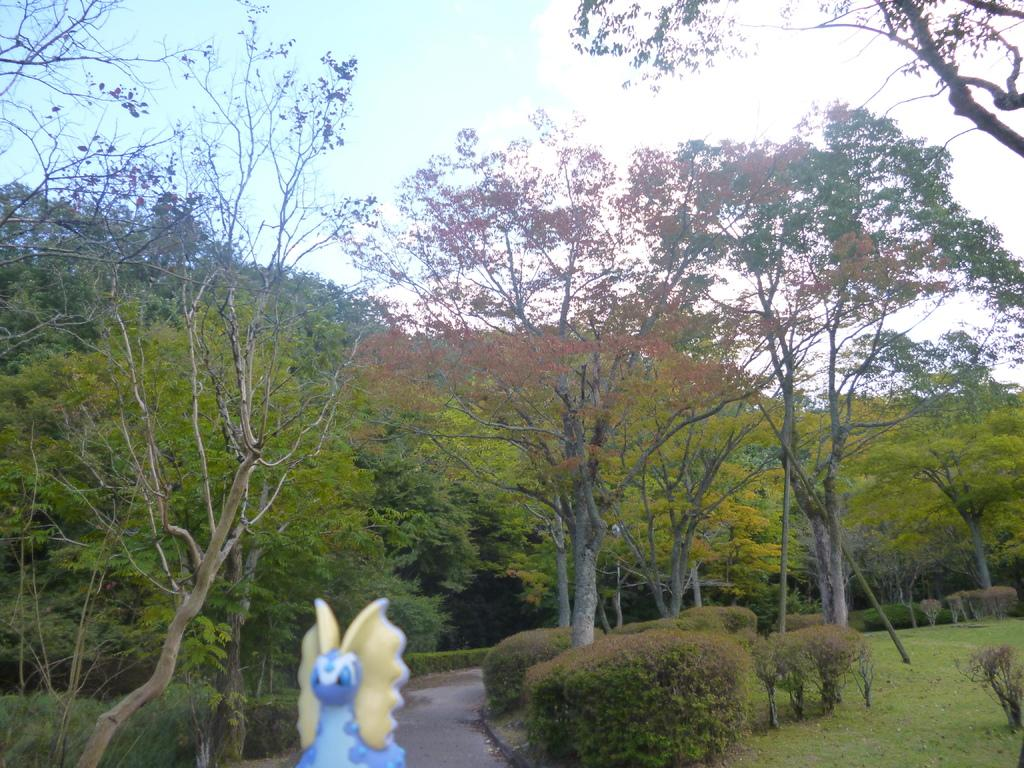What is the main subject of the image? There is a sculpture in the image. What else can be seen in the image besides the sculpture? There is a walking path, bushes, the ground, trees, and the sky visible in the image. Can you describe the walking path in the image? The walking path is a path that people can walk on. What is visible in the sky in the image? The sky is visible in the image, and clouds are present in the sky. What statement does the birthday kite make in the image? There is no birthday kite present in the image, so it cannot make any statements. 